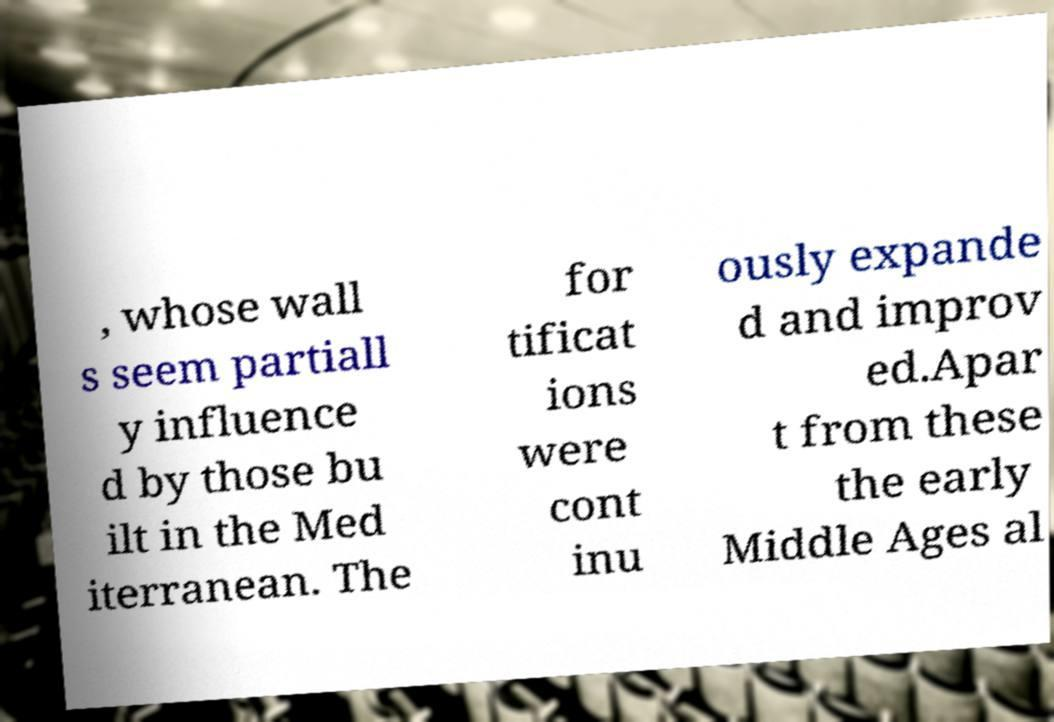Please read and relay the text visible in this image. What does it say? , whose wall s seem partiall y influence d by those bu ilt in the Med iterranean. The for tificat ions were cont inu ously expande d and improv ed.Apar t from these the early Middle Ages al 